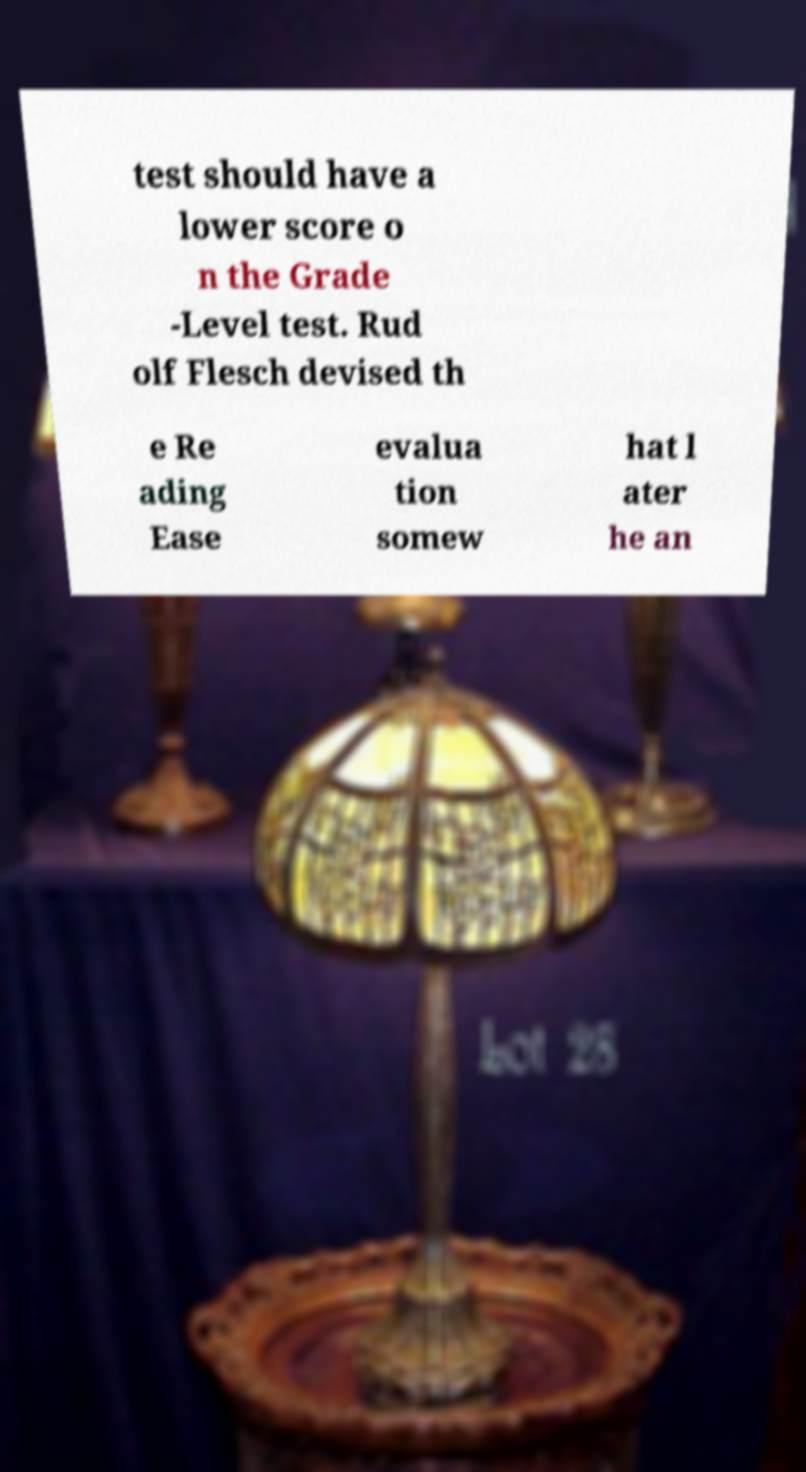Could you assist in decoding the text presented in this image and type it out clearly? test should have a lower score o n the Grade -Level test. Rud olf Flesch devised th e Re ading Ease evalua tion somew hat l ater he an 